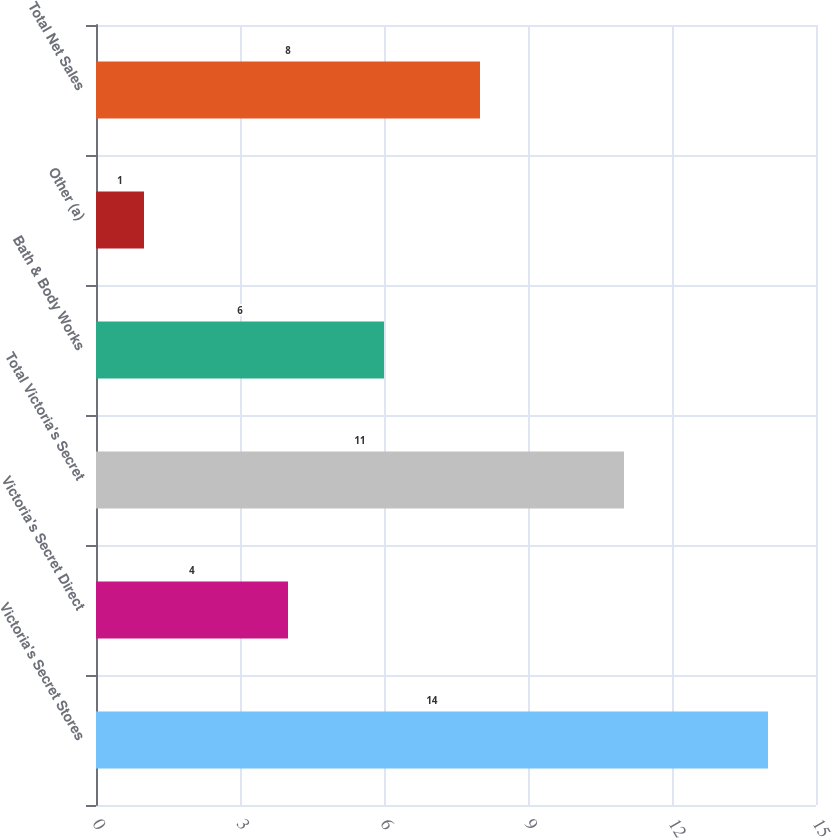<chart> <loc_0><loc_0><loc_500><loc_500><bar_chart><fcel>Victoria's Secret Stores<fcel>Victoria's Secret Direct<fcel>Total Victoria's Secret<fcel>Bath & Body Works<fcel>Other (a)<fcel>Total Net Sales<nl><fcel>14<fcel>4<fcel>11<fcel>6<fcel>1<fcel>8<nl></chart> 